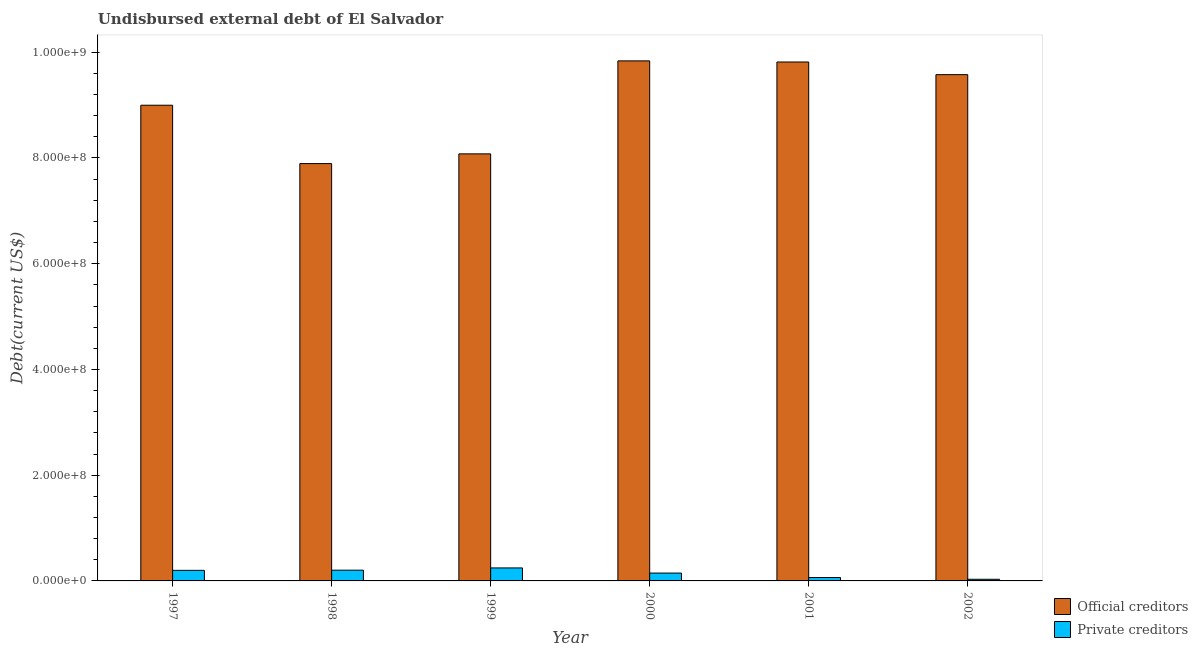Are the number of bars per tick equal to the number of legend labels?
Provide a short and direct response. Yes. How many bars are there on the 6th tick from the left?
Give a very brief answer. 2. How many bars are there on the 5th tick from the right?
Offer a very short reply. 2. What is the label of the 3rd group of bars from the left?
Your answer should be compact. 1999. In how many cases, is the number of bars for a given year not equal to the number of legend labels?
Your response must be concise. 0. What is the undisbursed external debt of official creditors in 1999?
Provide a succinct answer. 8.08e+08. Across all years, what is the maximum undisbursed external debt of official creditors?
Ensure brevity in your answer.  9.84e+08. Across all years, what is the minimum undisbursed external debt of official creditors?
Your answer should be very brief. 7.89e+08. In which year was the undisbursed external debt of official creditors maximum?
Keep it short and to the point. 2000. In which year was the undisbursed external debt of private creditors minimum?
Offer a terse response. 2002. What is the total undisbursed external debt of private creditors in the graph?
Ensure brevity in your answer.  8.93e+07. What is the difference between the undisbursed external debt of private creditors in 1997 and that in 2002?
Offer a very short reply. 1.69e+07. What is the difference between the undisbursed external debt of private creditors in 1997 and the undisbursed external debt of official creditors in 2000?
Your answer should be very brief. 5.15e+06. What is the average undisbursed external debt of official creditors per year?
Give a very brief answer. 9.03e+08. In the year 2001, what is the difference between the undisbursed external debt of official creditors and undisbursed external debt of private creditors?
Provide a succinct answer. 0. In how many years, is the undisbursed external debt of private creditors greater than 40000000 US$?
Make the answer very short. 0. What is the ratio of the undisbursed external debt of official creditors in 1999 to that in 2002?
Your answer should be very brief. 0.84. Is the undisbursed external debt of private creditors in 1998 less than that in 2002?
Provide a short and direct response. No. Is the difference between the undisbursed external debt of official creditors in 1999 and 2002 greater than the difference between the undisbursed external debt of private creditors in 1999 and 2002?
Your response must be concise. No. What is the difference between the highest and the second highest undisbursed external debt of private creditors?
Offer a very short reply. 4.27e+06. What is the difference between the highest and the lowest undisbursed external debt of official creditors?
Make the answer very short. 1.94e+08. In how many years, is the undisbursed external debt of private creditors greater than the average undisbursed external debt of private creditors taken over all years?
Provide a short and direct response. 3. Is the sum of the undisbursed external debt of private creditors in 1997 and 1999 greater than the maximum undisbursed external debt of official creditors across all years?
Provide a short and direct response. Yes. What does the 2nd bar from the left in 2000 represents?
Keep it short and to the point. Private creditors. What does the 2nd bar from the right in 1999 represents?
Offer a very short reply. Official creditors. How many years are there in the graph?
Provide a succinct answer. 6. Are the values on the major ticks of Y-axis written in scientific E-notation?
Your response must be concise. Yes. Does the graph contain any zero values?
Ensure brevity in your answer.  No. Does the graph contain grids?
Offer a very short reply. No. Where does the legend appear in the graph?
Provide a short and direct response. Bottom right. How are the legend labels stacked?
Ensure brevity in your answer.  Vertical. What is the title of the graph?
Offer a very short reply. Undisbursed external debt of El Salvador. What is the label or title of the Y-axis?
Your answer should be compact. Debt(current US$). What is the Debt(current US$) in Official creditors in 1997?
Ensure brevity in your answer.  9.00e+08. What is the Debt(current US$) of Private creditors in 1997?
Make the answer very short. 2.00e+07. What is the Debt(current US$) of Official creditors in 1998?
Provide a succinct answer. 7.89e+08. What is the Debt(current US$) of Private creditors in 1998?
Keep it short and to the point. 2.03e+07. What is the Debt(current US$) in Official creditors in 1999?
Offer a terse response. 8.08e+08. What is the Debt(current US$) in Private creditors in 1999?
Your response must be concise. 2.46e+07. What is the Debt(current US$) in Official creditors in 2000?
Give a very brief answer. 9.84e+08. What is the Debt(current US$) in Private creditors in 2000?
Your response must be concise. 1.49e+07. What is the Debt(current US$) of Official creditors in 2001?
Your answer should be very brief. 9.82e+08. What is the Debt(current US$) in Private creditors in 2001?
Keep it short and to the point. 6.40e+06. What is the Debt(current US$) of Official creditors in 2002?
Provide a short and direct response. 9.58e+08. What is the Debt(current US$) in Private creditors in 2002?
Keep it short and to the point. 3.11e+06. Across all years, what is the maximum Debt(current US$) in Official creditors?
Ensure brevity in your answer.  9.84e+08. Across all years, what is the maximum Debt(current US$) in Private creditors?
Your answer should be compact. 2.46e+07. Across all years, what is the minimum Debt(current US$) in Official creditors?
Provide a succinct answer. 7.89e+08. Across all years, what is the minimum Debt(current US$) in Private creditors?
Your answer should be compact. 3.11e+06. What is the total Debt(current US$) of Official creditors in the graph?
Your response must be concise. 5.42e+09. What is the total Debt(current US$) of Private creditors in the graph?
Provide a succinct answer. 8.93e+07. What is the difference between the Debt(current US$) of Official creditors in 1997 and that in 1998?
Provide a short and direct response. 1.10e+08. What is the difference between the Debt(current US$) in Private creditors in 1997 and that in 1998?
Ensure brevity in your answer.  -2.99e+05. What is the difference between the Debt(current US$) in Official creditors in 1997 and that in 1999?
Ensure brevity in your answer.  9.20e+07. What is the difference between the Debt(current US$) in Private creditors in 1997 and that in 1999?
Your answer should be compact. -4.57e+06. What is the difference between the Debt(current US$) of Official creditors in 1997 and that in 2000?
Your response must be concise. -8.39e+07. What is the difference between the Debt(current US$) in Private creditors in 1997 and that in 2000?
Your answer should be very brief. 5.15e+06. What is the difference between the Debt(current US$) of Official creditors in 1997 and that in 2001?
Your response must be concise. -8.18e+07. What is the difference between the Debt(current US$) in Private creditors in 1997 and that in 2001?
Offer a terse response. 1.36e+07. What is the difference between the Debt(current US$) of Official creditors in 1997 and that in 2002?
Keep it short and to the point. -5.78e+07. What is the difference between the Debt(current US$) of Private creditors in 1997 and that in 2002?
Your answer should be compact. 1.69e+07. What is the difference between the Debt(current US$) of Official creditors in 1998 and that in 1999?
Provide a short and direct response. -1.84e+07. What is the difference between the Debt(current US$) in Private creditors in 1998 and that in 1999?
Your answer should be very brief. -4.27e+06. What is the difference between the Debt(current US$) of Official creditors in 1998 and that in 2000?
Ensure brevity in your answer.  -1.94e+08. What is the difference between the Debt(current US$) of Private creditors in 1998 and that in 2000?
Give a very brief answer. 5.45e+06. What is the difference between the Debt(current US$) in Official creditors in 1998 and that in 2001?
Offer a terse response. -1.92e+08. What is the difference between the Debt(current US$) of Private creditors in 1998 and that in 2001?
Offer a terse response. 1.39e+07. What is the difference between the Debt(current US$) in Official creditors in 1998 and that in 2002?
Make the answer very short. -1.68e+08. What is the difference between the Debt(current US$) in Private creditors in 1998 and that in 2002?
Your response must be concise. 1.72e+07. What is the difference between the Debt(current US$) in Official creditors in 1999 and that in 2000?
Give a very brief answer. -1.76e+08. What is the difference between the Debt(current US$) in Private creditors in 1999 and that in 2000?
Your response must be concise. 9.72e+06. What is the difference between the Debt(current US$) of Official creditors in 1999 and that in 2001?
Provide a short and direct response. -1.74e+08. What is the difference between the Debt(current US$) in Private creditors in 1999 and that in 2001?
Provide a succinct answer. 1.82e+07. What is the difference between the Debt(current US$) in Official creditors in 1999 and that in 2002?
Ensure brevity in your answer.  -1.50e+08. What is the difference between the Debt(current US$) in Private creditors in 1999 and that in 2002?
Give a very brief answer. 2.15e+07. What is the difference between the Debt(current US$) in Official creditors in 2000 and that in 2001?
Keep it short and to the point. 2.10e+06. What is the difference between the Debt(current US$) of Private creditors in 2000 and that in 2001?
Offer a very short reply. 8.46e+06. What is the difference between the Debt(current US$) in Official creditors in 2000 and that in 2002?
Make the answer very short. 2.60e+07. What is the difference between the Debt(current US$) of Private creditors in 2000 and that in 2002?
Keep it short and to the point. 1.17e+07. What is the difference between the Debt(current US$) in Official creditors in 2001 and that in 2002?
Give a very brief answer. 2.39e+07. What is the difference between the Debt(current US$) in Private creditors in 2001 and that in 2002?
Your answer should be compact. 3.29e+06. What is the difference between the Debt(current US$) in Official creditors in 1997 and the Debt(current US$) in Private creditors in 1998?
Provide a short and direct response. 8.80e+08. What is the difference between the Debt(current US$) of Official creditors in 1997 and the Debt(current US$) of Private creditors in 1999?
Your answer should be compact. 8.75e+08. What is the difference between the Debt(current US$) of Official creditors in 1997 and the Debt(current US$) of Private creditors in 2000?
Offer a terse response. 8.85e+08. What is the difference between the Debt(current US$) in Official creditors in 1997 and the Debt(current US$) in Private creditors in 2001?
Provide a short and direct response. 8.93e+08. What is the difference between the Debt(current US$) in Official creditors in 1997 and the Debt(current US$) in Private creditors in 2002?
Your answer should be very brief. 8.97e+08. What is the difference between the Debt(current US$) in Official creditors in 1998 and the Debt(current US$) in Private creditors in 1999?
Make the answer very short. 7.65e+08. What is the difference between the Debt(current US$) of Official creditors in 1998 and the Debt(current US$) of Private creditors in 2000?
Provide a succinct answer. 7.75e+08. What is the difference between the Debt(current US$) of Official creditors in 1998 and the Debt(current US$) of Private creditors in 2001?
Offer a very short reply. 7.83e+08. What is the difference between the Debt(current US$) of Official creditors in 1998 and the Debt(current US$) of Private creditors in 2002?
Offer a terse response. 7.86e+08. What is the difference between the Debt(current US$) in Official creditors in 1999 and the Debt(current US$) in Private creditors in 2000?
Offer a terse response. 7.93e+08. What is the difference between the Debt(current US$) of Official creditors in 1999 and the Debt(current US$) of Private creditors in 2001?
Keep it short and to the point. 8.01e+08. What is the difference between the Debt(current US$) in Official creditors in 1999 and the Debt(current US$) in Private creditors in 2002?
Provide a short and direct response. 8.05e+08. What is the difference between the Debt(current US$) in Official creditors in 2000 and the Debt(current US$) in Private creditors in 2001?
Offer a very short reply. 9.77e+08. What is the difference between the Debt(current US$) in Official creditors in 2000 and the Debt(current US$) in Private creditors in 2002?
Your answer should be compact. 9.81e+08. What is the difference between the Debt(current US$) in Official creditors in 2001 and the Debt(current US$) in Private creditors in 2002?
Provide a succinct answer. 9.78e+08. What is the average Debt(current US$) in Official creditors per year?
Offer a very short reply. 9.03e+08. What is the average Debt(current US$) in Private creditors per year?
Offer a terse response. 1.49e+07. In the year 1997, what is the difference between the Debt(current US$) of Official creditors and Debt(current US$) of Private creditors?
Your response must be concise. 8.80e+08. In the year 1998, what is the difference between the Debt(current US$) of Official creditors and Debt(current US$) of Private creditors?
Provide a succinct answer. 7.69e+08. In the year 1999, what is the difference between the Debt(current US$) in Official creditors and Debt(current US$) in Private creditors?
Your response must be concise. 7.83e+08. In the year 2000, what is the difference between the Debt(current US$) of Official creditors and Debt(current US$) of Private creditors?
Provide a succinct answer. 9.69e+08. In the year 2001, what is the difference between the Debt(current US$) of Official creditors and Debt(current US$) of Private creditors?
Your response must be concise. 9.75e+08. In the year 2002, what is the difference between the Debt(current US$) in Official creditors and Debt(current US$) in Private creditors?
Provide a succinct answer. 9.55e+08. What is the ratio of the Debt(current US$) of Official creditors in 1997 to that in 1998?
Your response must be concise. 1.14. What is the ratio of the Debt(current US$) of Private creditors in 1997 to that in 1998?
Offer a very short reply. 0.99. What is the ratio of the Debt(current US$) of Official creditors in 1997 to that in 1999?
Offer a terse response. 1.11. What is the ratio of the Debt(current US$) in Private creditors in 1997 to that in 1999?
Give a very brief answer. 0.81. What is the ratio of the Debt(current US$) in Official creditors in 1997 to that in 2000?
Ensure brevity in your answer.  0.91. What is the ratio of the Debt(current US$) of Private creditors in 1997 to that in 2000?
Your response must be concise. 1.35. What is the ratio of the Debt(current US$) of Private creditors in 1997 to that in 2001?
Provide a succinct answer. 3.13. What is the ratio of the Debt(current US$) of Official creditors in 1997 to that in 2002?
Your response must be concise. 0.94. What is the ratio of the Debt(current US$) of Private creditors in 1997 to that in 2002?
Give a very brief answer. 6.44. What is the ratio of the Debt(current US$) of Official creditors in 1998 to that in 1999?
Offer a very short reply. 0.98. What is the ratio of the Debt(current US$) of Private creditors in 1998 to that in 1999?
Provide a short and direct response. 0.83. What is the ratio of the Debt(current US$) in Official creditors in 1998 to that in 2000?
Offer a very short reply. 0.8. What is the ratio of the Debt(current US$) of Private creditors in 1998 to that in 2000?
Give a very brief answer. 1.37. What is the ratio of the Debt(current US$) in Official creditors in 1998 to that in 2001?
Make the answer very short. 0.8. What is the ratio of the Debt(current US$) in Private creditors in 1998 to that in 2001?
Make the answer very short. 3.17. What is the ratio of the Debt(current US$) in Official creditors in 1998 to that in 2002?
Keep it short and to the point. 0.82. What is the ratio of the Debt(current US$) of Private creditors in 1998 to that in 2002?
Provide a short and direct response. 6.53. What is the ratio of the Debt(current US$) of Official creditors in 1999 to that in 2000?
Keep it short and to the point. 0.82. What is the ratio of the Debt(current US$) of Private creditors in 1999 to that in 2000?
Provide a short and direct response. 1.65. What is the ratio of the Debt(current US$) of Official creditors in 1999 to that in 2001?
Offer a terse response. 0.82. What is the ratio of the Debt(current US$) in Private creditors in 1999 to that in 2001?
Give a very brief answer. 3.84. What is the ratio of the Debt(current US$) in Official creditors in 1999 to that in 2002?
Provide a succinct answer. 0.84. What is the ratio of the Debt(current US$) of Private creditors in 1999 to that in 2002?
Provide a succinct answer. 7.91. What is the ratio of the Debt(current US$) of Private creditors in 2000 to that in 2001?
Ensure brevity in your answer.  2.32. What is the ratio of the Debt(current US$) of Official creditors in 2000 to that in 2002?
Your response must be concise. 1.03. What is the ratio of the Debt(current US$) of Private creditors in 2000 to that in 2002?
Provide a succinct answer. 4.78. What is the ratio of the Debt(current US$) in Private creditors in 2001 to that in 2002?
Your answer should be very brief. 2.06. What is the difference between the highest and the second highest Debt(current US$) of Official creditors?
Keep it short and to the point. 2.10e+06. What is the difference between the highest and the second highest Debt(current US$) of Private creditors?
Provide a short and direct response. 4.27e+06. What is the difference between the highest and the lowest Debt(current US$) of Official creditors?
Your response must be concise. 1.94e+08. What is the difference between the highest and the lowest Debt(current US$) in Private creditors?
Provide a short and direct response. 2.15e+07. 